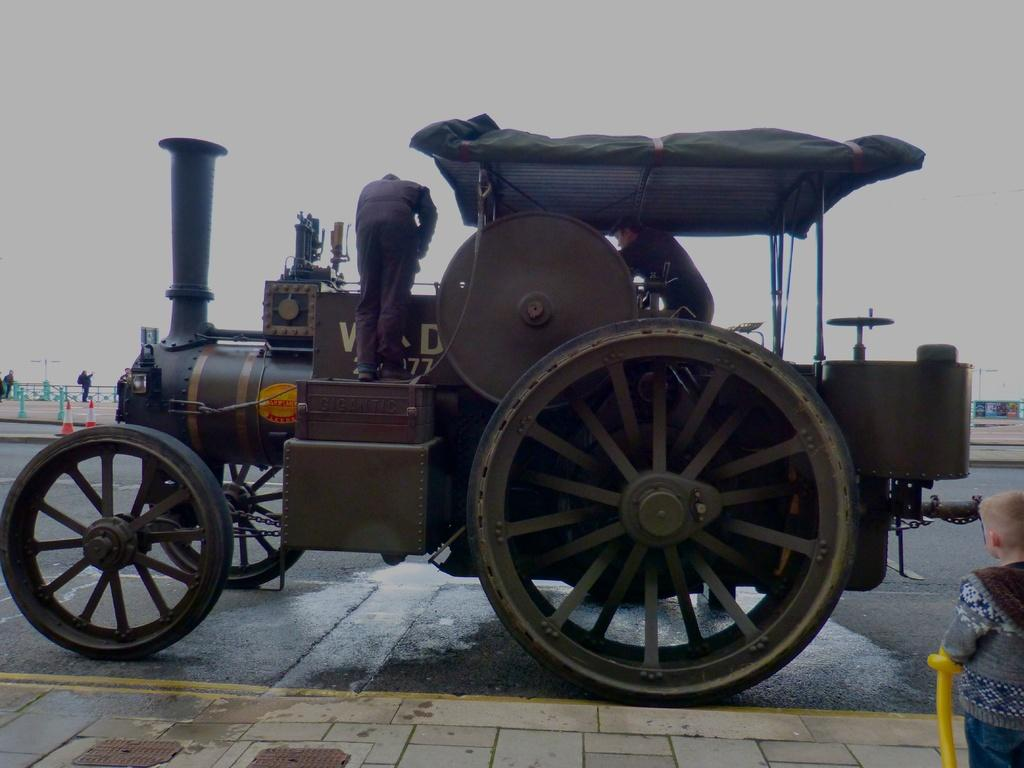What is the main subject of the image? There is a vehicle on the road in the image. Are there any passengers on the vehicle? Yes, there are people on the vehicle. What can be seen in the distance in the image? The sky is visible in the background of the image. What else is present on the ground in the background of the image? There are other objects on the ground in the background of the image. How many eggs are visible on the vehicle in the image? There are no eggs present on the vehicle or in the image. 